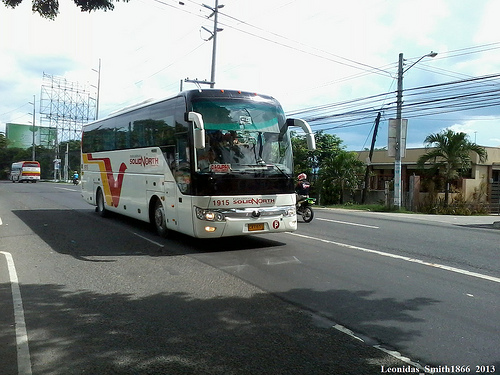Please provide a short description for this region: [0.37, 0.34, 0.64, 0.43]. Two rear view mirrors of vehicles. 